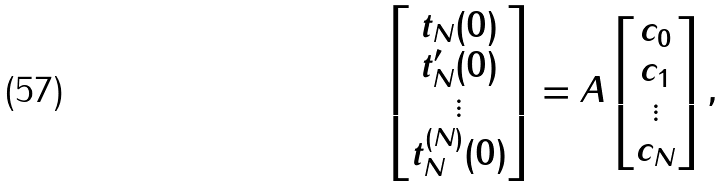<formula> <loc_0><loc_0><loc_500><loc_500>\begin{bmatrix} t _ { N } ( 0 ) \\ t ^ { \prime } _ { N } ( 0 ) \\ \vdots \\ t ^ { ( N ) } _ { N } ( 0 ) \end{bmatrix} = A \begin{bmatrix} c _ { 0 } \\ c _ { 1 } \\ \vdots \\ c _ { N } \end{bmatrix} ,</formula> 